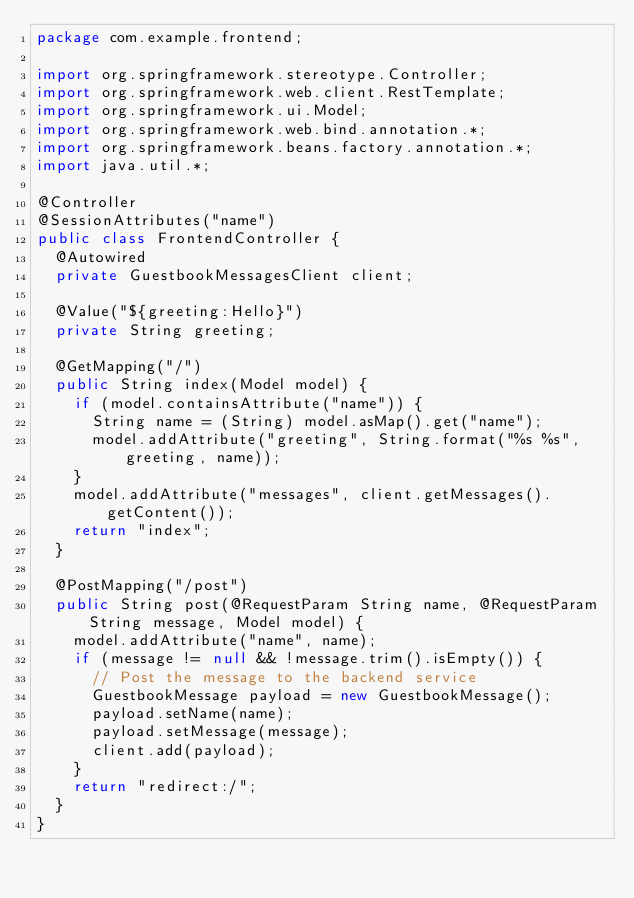Convert code to text. <code><loc_0><loc_0><loc_500><loc_500><_Java_>package com.example.frontend;

import org.springframework.stereotype.Controller;
import org.springframework.web.client.RestTemplate;
import org.springframework.ui.Model;
import org.springframework.web.bind.annotation.*;
import org.springframework.beans.factory.annotation.*;
import java.util.*;

@Controller
@SessionAttributes("name")
public class FrontendController {
	@Autowired
	private GuestbookMessagesClient client;
	
	@Value("${greeting:Hello}")
	private String greeting;
	
	@GetMapping("/")
	public String index(Model model) {
		if (model.containsAttribute("name")) {
			String name = (String) model.asMap().get("name");
			model.addAttribute("greeting", String.format("%s %s", greeting, name));
		}
		model.addAttribute("messages", client.getMessages().getContent());
		return "index";
	}
	
	@PostMapping("/post")
	public String post(@RequestParam String name, @RequestParam String message, Model model) {
		model.addAttribute("name", name);
		if (message != null && !message.trim().isEmpty()) {
			// Post the message to the backend service
			GuestbookMessage payload = new GuestbookMessage();
			payload.setName(name);
			payload.setMessage(message);
			client.add(payload);
		}
		return "redirect:/";
  }
}

</code> 